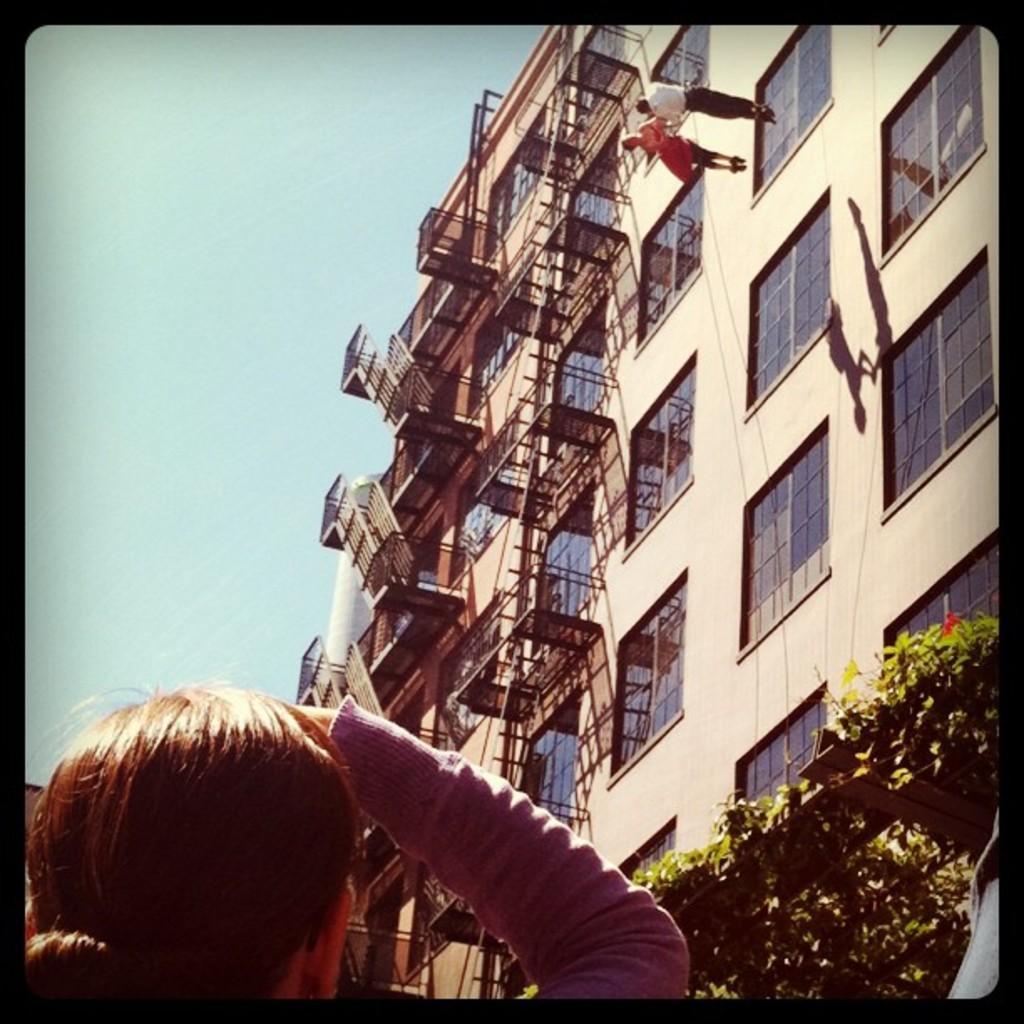Describe this image in one or two sentences. At the bottom of the image there is a woman. To the right side of the image there is a building with staircase ,windows. At the bottom of the image to the right side there are plants. 